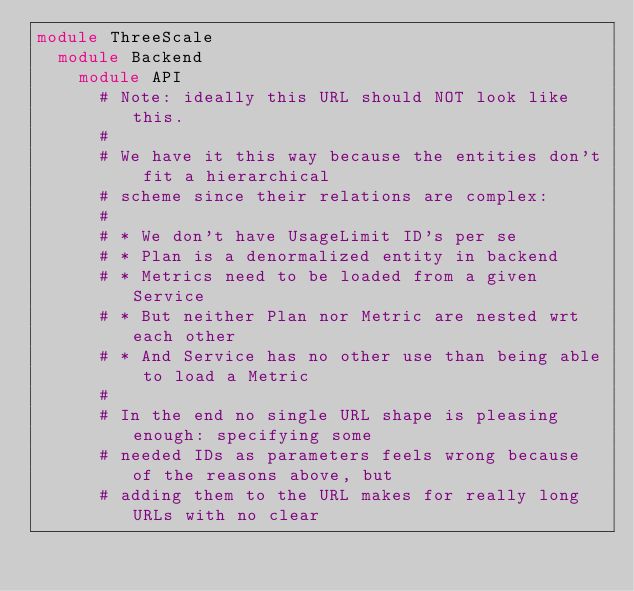Convert code to text. <code><loc_0><loc_0><loc_500><loc_500><_Ruby_>module ThreeScale
  module Backend
    module API
      # Note: ideally this URL should NOT look like this.
      #
      # We have it this way because the entities don't fit a hierarchical
      # scheme since their relations are complex:
      #
      # * We don't have UsageLimit ID's per se
      # * Plan is a denormalized entity in backend
      # * Metrics need to be loaded from a given Service
      # * But neither Plan nor Metric are nested wrt each other
      # * And Service has no other use than being able to load a Metric
      #
      # In the end no single URL shape is pleasing enough: specifying some
      # needed IDs as parameters feels wrong because of the reasons above, but
      # adding them to the URL makes for really long URLs with no clear</code> 